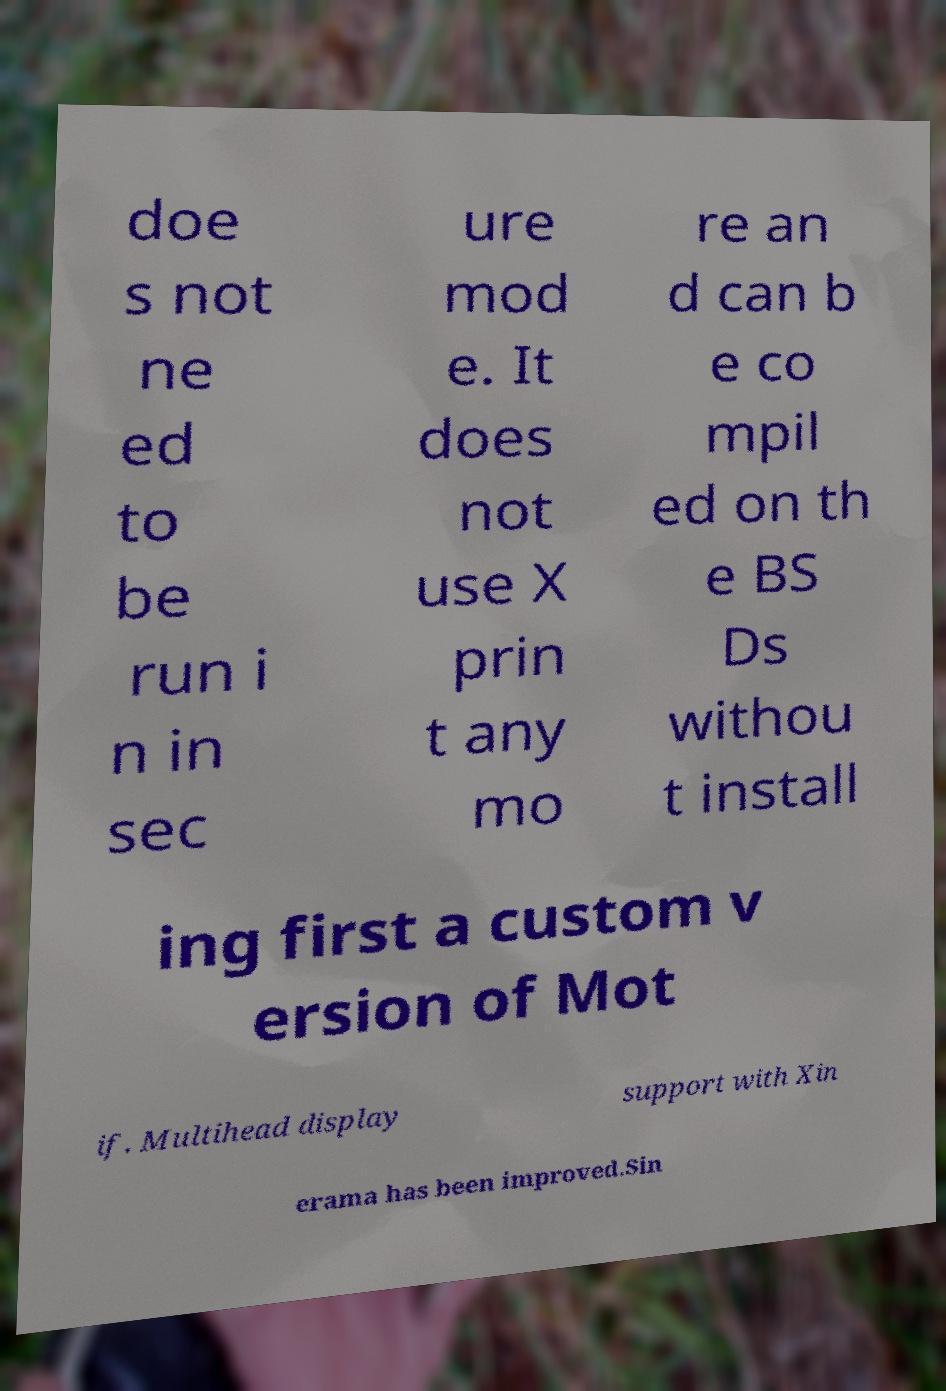Could you extract and type out the text from this image? doe s not ne ed to be run i n in sec ure mod e. It does not use X prin t any mo re an d can b e co mpil ed on th e BS Ds withou t install ing first a custom v ersion of Mot if. Multihead display support with Xin erama has been improved.Sin 